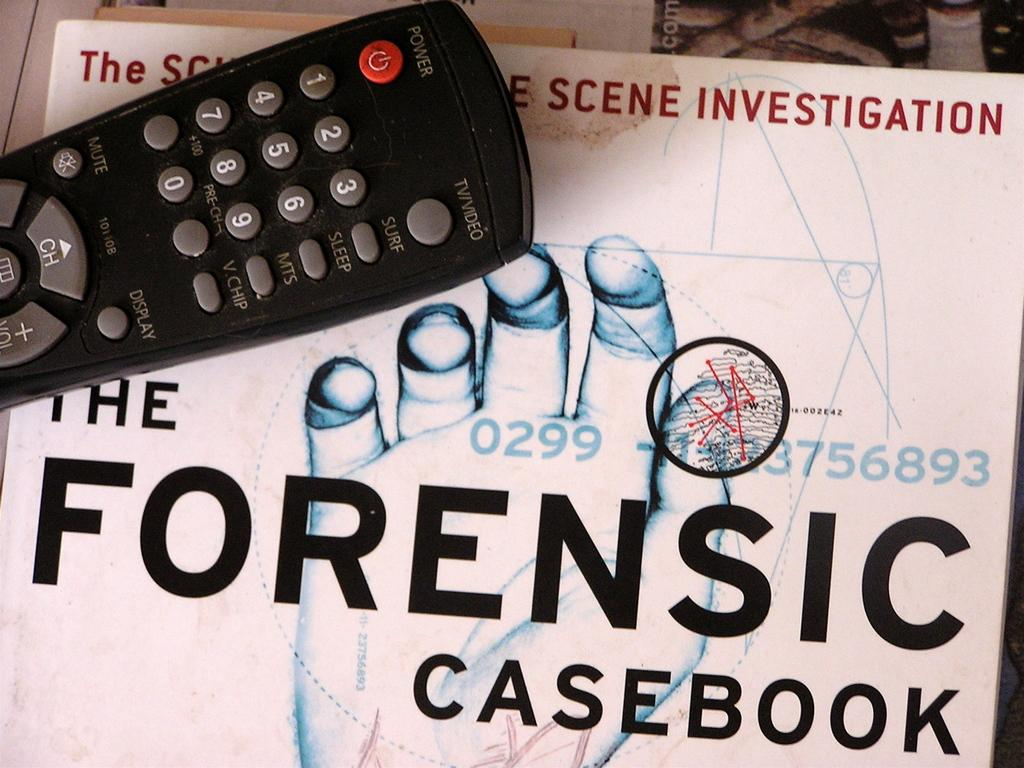<image>
Render a clear and concise summary of the photo. A tv remote sitting on top of a book called The Forensic Casebook. 